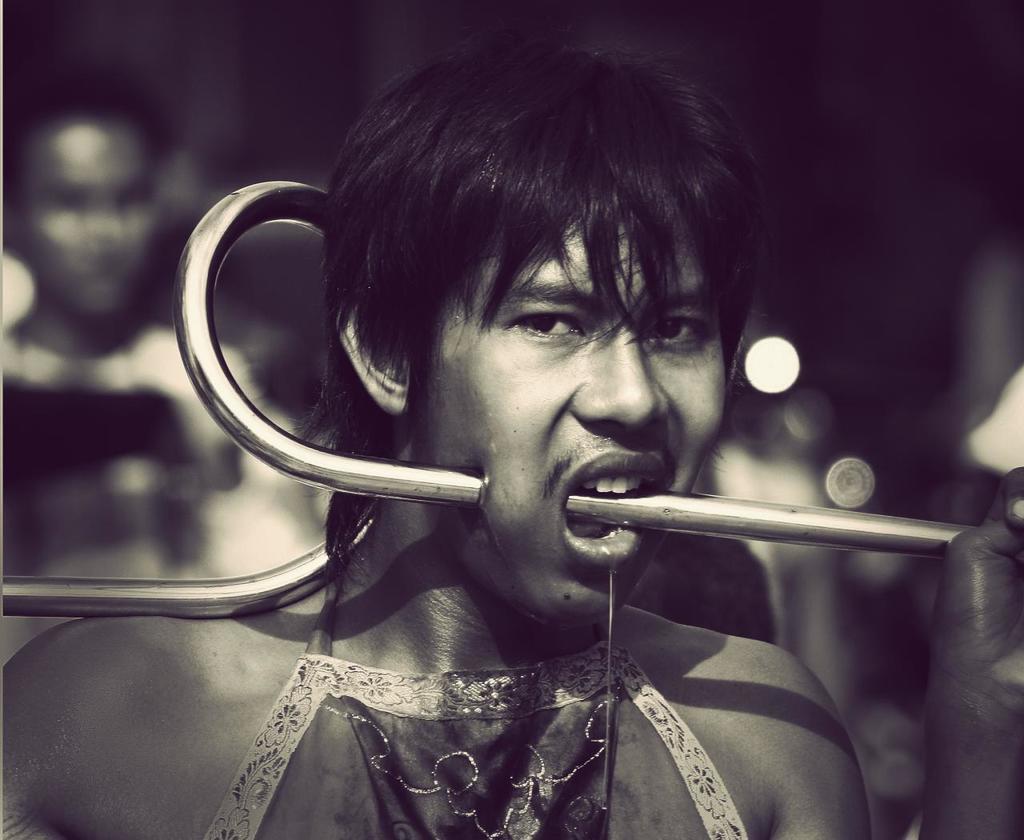Can you describe this image briefly? In this image we can see a person who kept steel rod in his mouth and the background is blurry. 